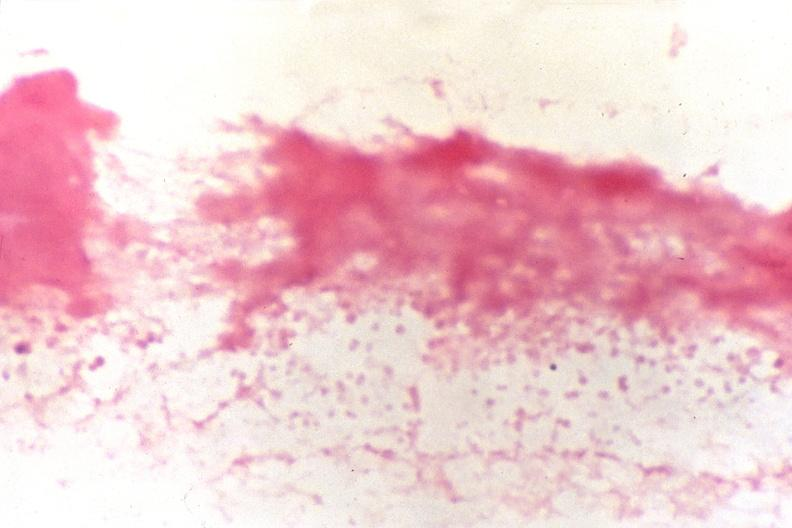s organisms present?
Answer the question using a single word or phrase. No 